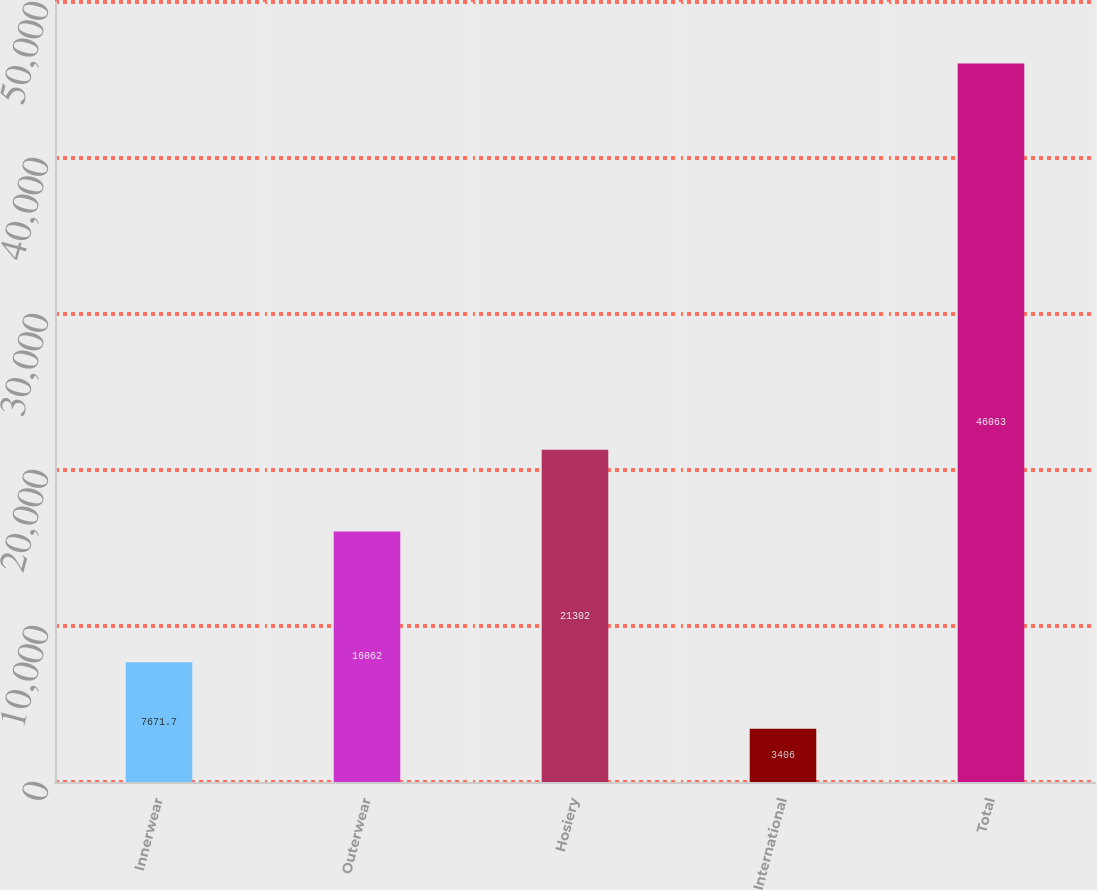<chart> <loc_0><loc_0><loc_500><loc_500><bar_chart><fcel>Innerwear<fcel>Outerwear<fcel>Hosiery<fcel>International<fcel>Total<nl><fcel>7671.7<fcel>16062<fcel>21302<fcel>3406<fcel>46063<nl></chart> 